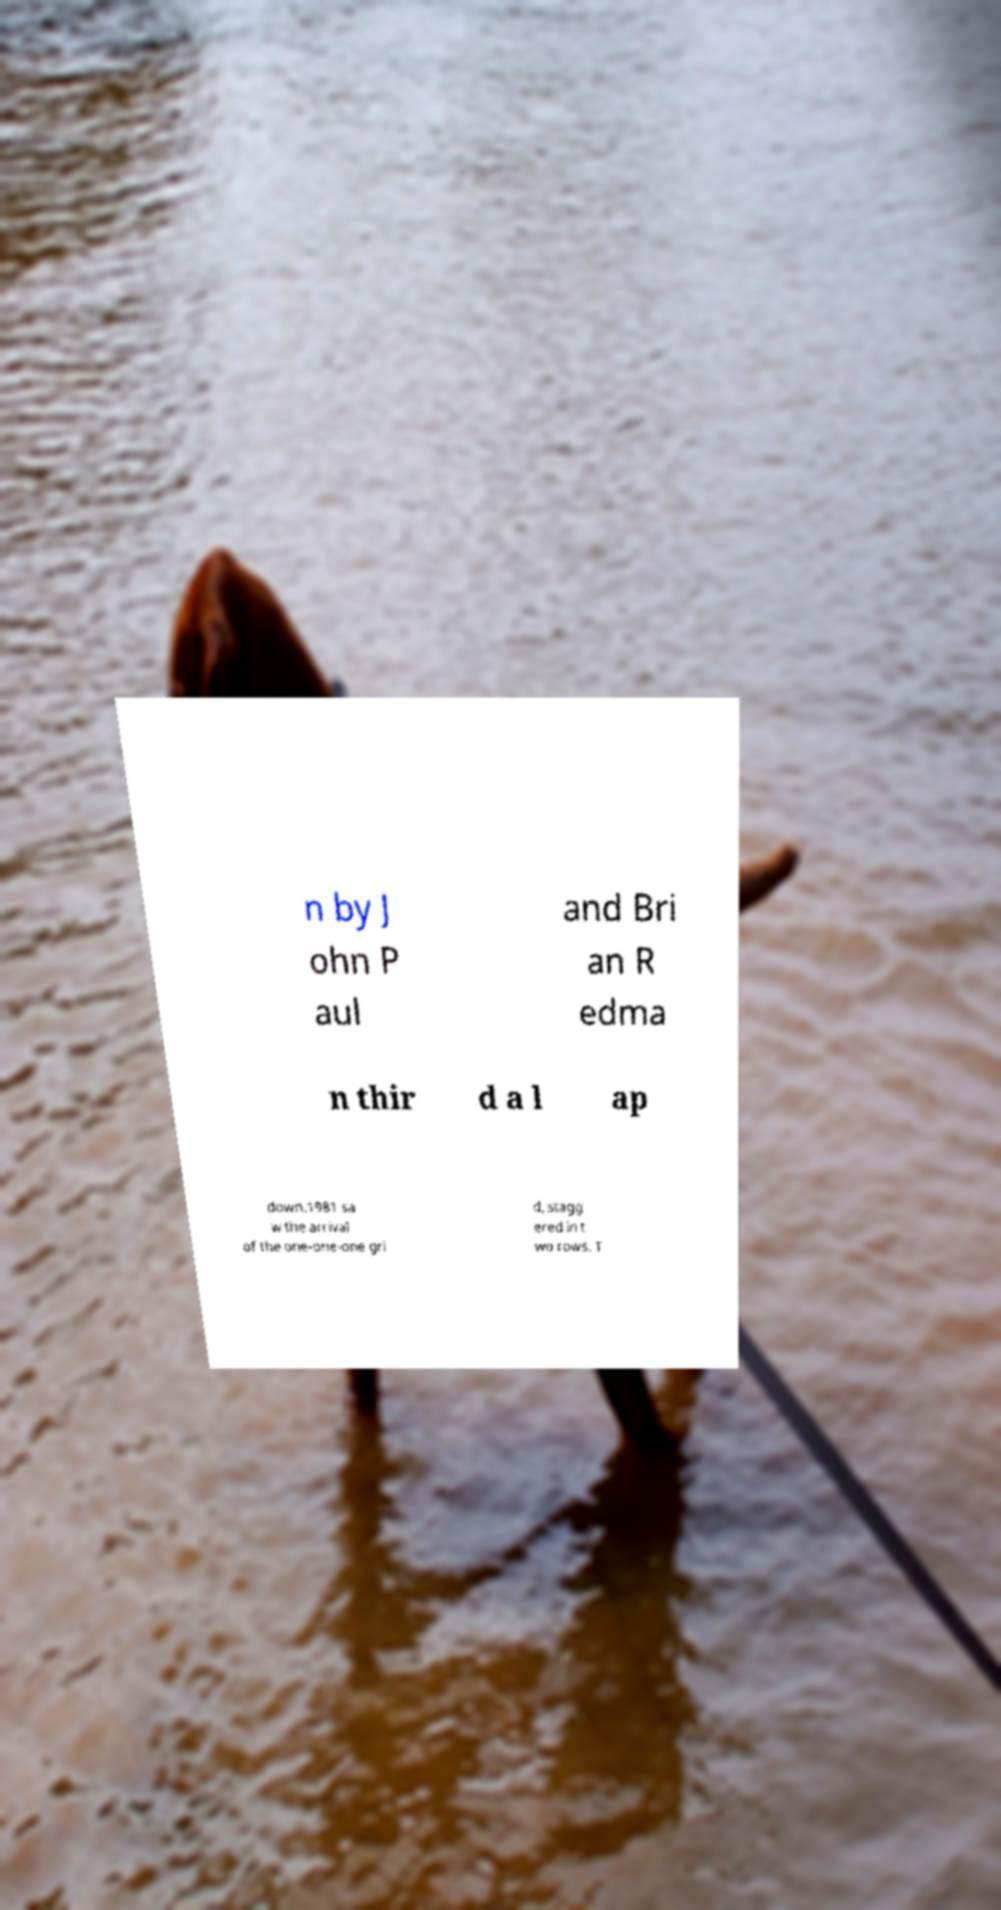Please read and relay the text visible in this image. What does it say? n by J ohn P aul and Bri an R edma n thir d a l ap down.1981 sa w the arrival of the one-one-one gri d, stagg ered in t wo rows. T 